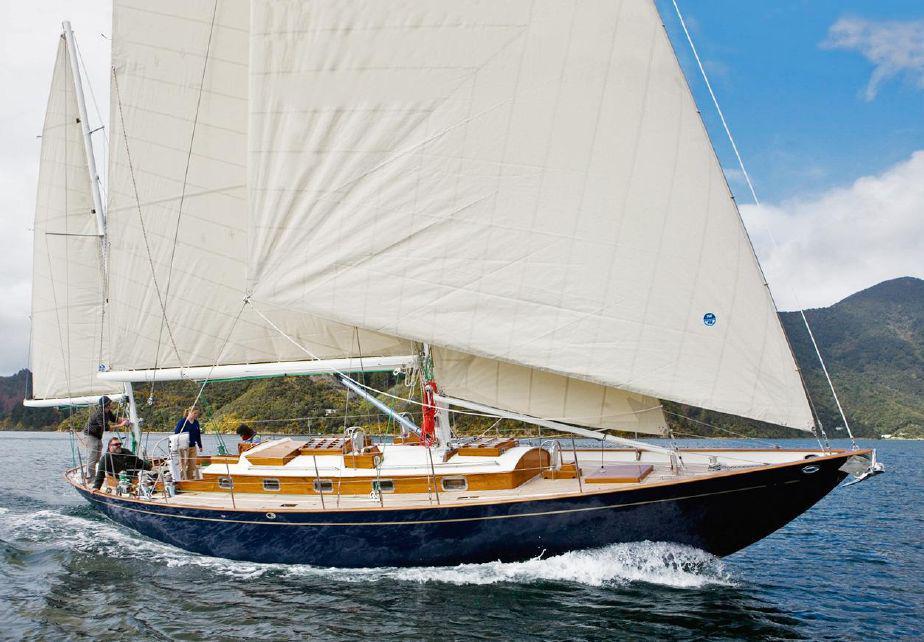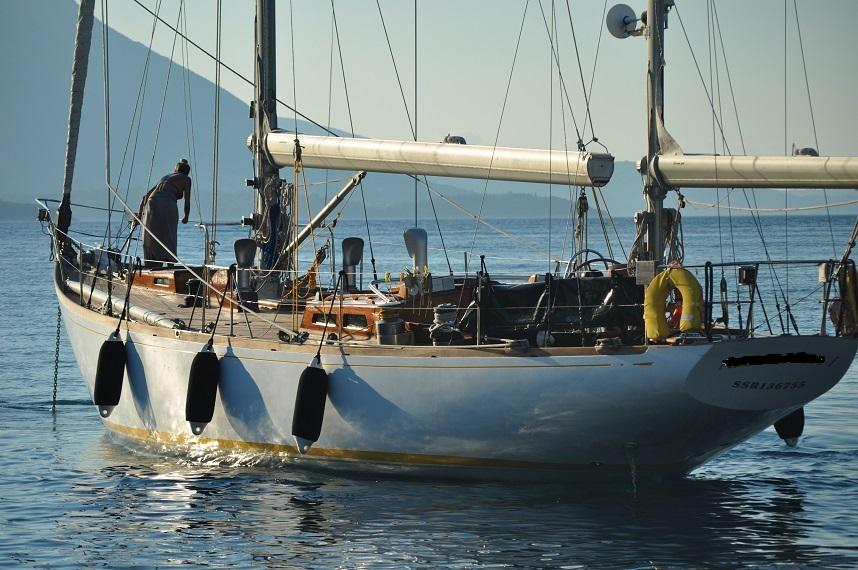The first image is the image on the left, the second image is the image on the right. Evaluate the accuracy of this statement regarding the images: "One sailboat has its sails furled and the other has sails unfurled.". Is it true? Answer yes or no. Yes. The first image is the image on the left, the second image is the image on the right. Considering the images on both sides, is "One of the sailboats is blue." valid? Answer yes or no. Yes. 